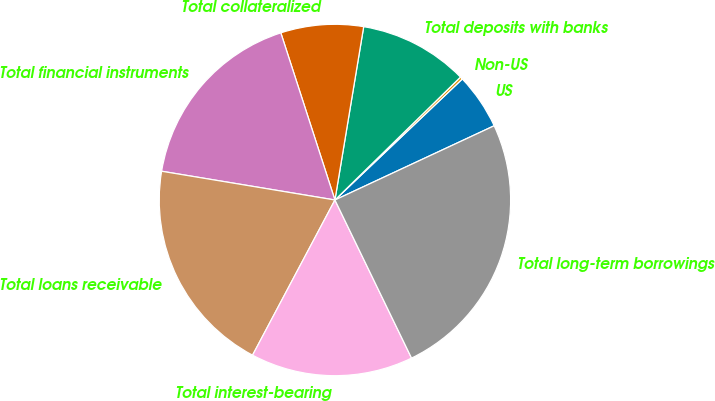Convert chart to OTSL. <chart><loc_0><loc_0><loc_500><loc_500><pie_chart><fcel>US<fcel>Non-US<fcel>Total deposits with banks<fcel>Total collateralized<fcel>Total financial instruments<fcel>Total loans receivable<fcel>Total interest-bearing<fcel>Total long-term borrowings<nl><fcel>5.15%<fcel>0.24%<fcel>10.05%<fcel>7.6%<fcel>17.4%<fcel>19.85%<fcel>14.95%<fcel>24.76%<nl></chart> 